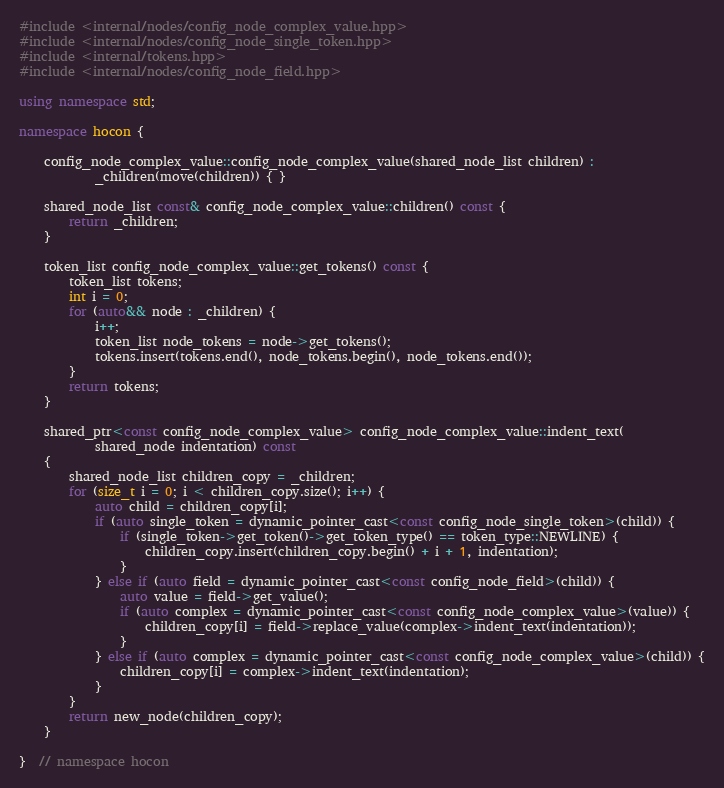<code> <loc_0><loc_0><loc_500><loc_500><_C++_>#include <internal/nodes/config_node_complex_value.hpp>
#include <internal/nodes/config_node_single_token.hpp>
#include <internal/tokens.hpp>
#include <internal/nodes/config_node_field.hpp>

using namespace std;

namespace hocon {

    config_node_complex_value::config_node_complex_value(shared_node_list children) :
            _children(move(children)) { }

    shared_node_list const& config_node_complex_value::children() const {
        return _children;
    }

    token_list config_node_complex_value::get_tokens() const {
        token_list tokens;
        int i = 0;
        for (auto&& node : _children) {
            i++;
            token_list node_tokens = node->get_tokens();
            tokens.insert(tokens.end(), node_tokens.begin(), node_tokens.end());
        }
        return tokens;
    }

    shared_ptr<const config_node_complex_value> config_node_complex_value::indent_text(
            shared_node indentation) const
    {
        shared_node_list children_copy = _children;
        for (size_t i = 0; i < children_copy.size(); i++) {
            auto child = children_copy[i];
            if (auto single_token = dynamic_pointer_cast<const config_node_single_token>(child)) {
                if (single_token->get_token()->get_token_type() == token_type::NEWLINE) {
                    children_copy.insert(children_copy.begin() + i + 1, indentation);
                }
            } else if (auto field = dynamic_pointer_cast<const config_node_field>(child)) {
                auto value = field->get_value();
                if (auto complex = dynamic_pointer_cast<const config_node_complex_value>(value)) {
                    children_copy[i] = field->replace_value(complex->indent_text(indentation));
                }
            } else if (auto complex = dynamic_pointer_cast<const config_node_complex_value>(child)) {
                children_copy[i] = complex->indent_text(indentation);
            }
        }
        return new_node(children_copy);
    }

}  // namespace hocon
</code> 